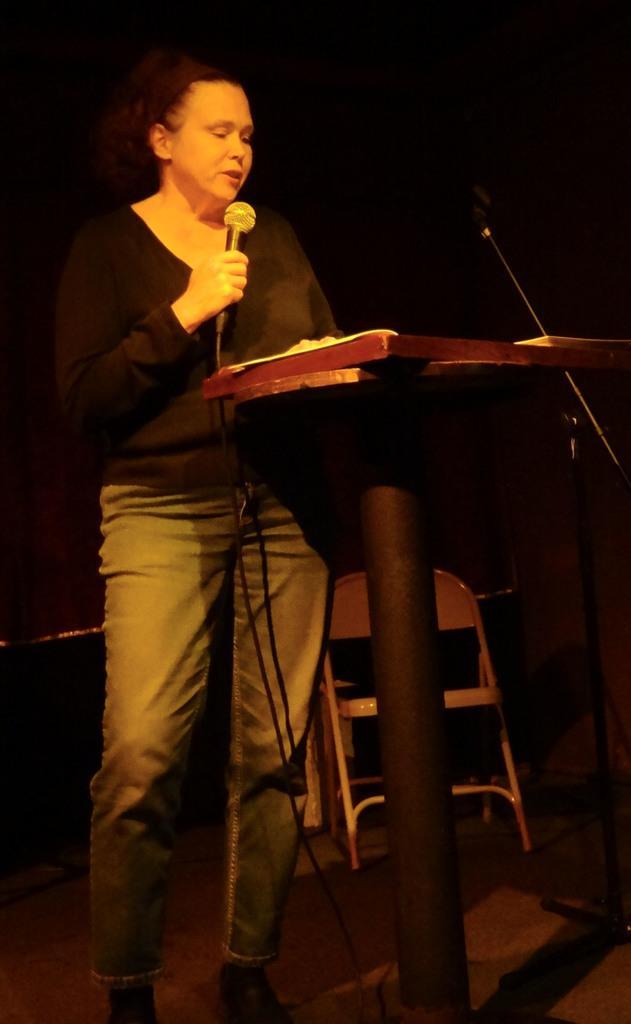Describe this image in one or two sentences. In this picture there is a woman holding a mic, in front of her there is a podium. In the background there is a chair and a microphone. The background is dark. 